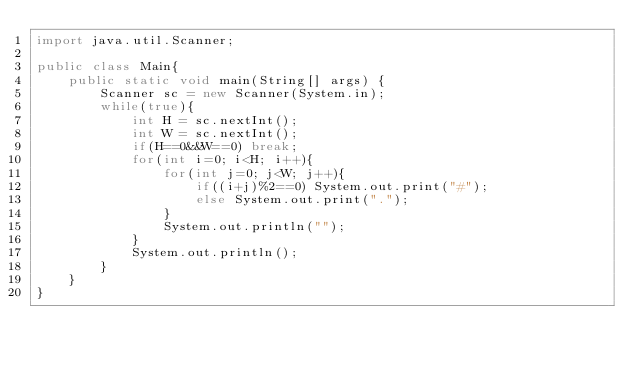Convert code to text. <code><loc_0><loc_0><loc_500><loc_500><_Java_>import java.util.Scanner;

public class Main{
    public static void main(String[] args) {
        Scanner sc = new Scanner(System.in);
        while(true){
            int H = sc.nextInt();
            int W = sc.nextInt();
            if(H==0&&W==0) break;
            for(int i=0; i<H; i++){
                for(int j=0; j<W; j++){
                    if((i+j)%2==0) System.out.print("#");
                    else System.out.print(".");
                }
                System.out.println("");
            }
            System.out.println();
        }
    }
}
</code> 